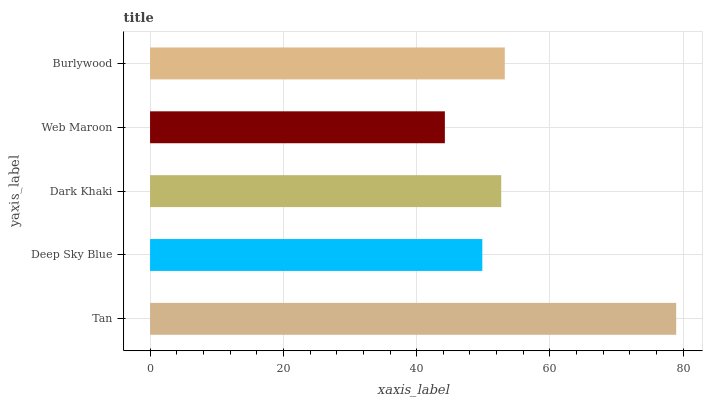Is Web Maroon the minimum?
Answer yes or no. Yes. Is Tan the maximum?
Answer yes or no. Yes. Is Deep Sky Blue the minimum?
Answer yes or no. No. Is Deep Sky Blue the maximum?
Answer yes or no. No. Is Tan greater than Deep Sky Blue?
Answer yes or no. Yes. Is Deep Sky Blue less than Tan?
Answer yes or no. Yes. Is Deep Sky Blue greater than Tan?
Answer yes or no. No. Is Tan less than Deep Sky Blue?
Answer yes or no. No. Is Dark Khaki the high median?
Answer yes or no. Yes. Is Dark Khaki the low median?
Answer yes or no. Yes. Is Burlywood the high median?
Answer yes or no. No. Is Deep Sky Blue the low median?
Answer yes or no. No. 